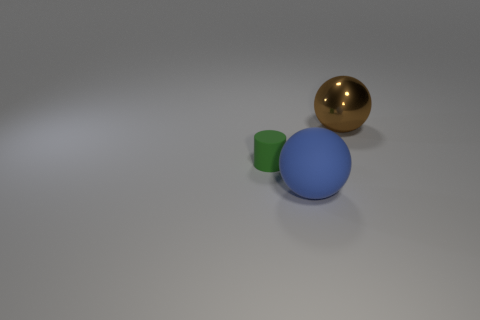Imagine these objects are part of a game, what could be the rules involving their interaction? In a hypothetical game, one could assign the spheres the role of movement pieces and the cylinder as an obstacle or goal. For example, players might need to navigate the spheres around the cylinder to reach a target area, gaining points for precision and speed, with the blue sphere worth one point and the gold sphere worth three due to its larger size. 